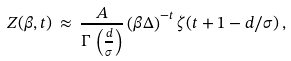Convert formula to latex. <formula><loc_0><loc_0><loc_500><loc_500>Z ( \beta , t ) \, \approx \, \frac { A } { \Gamma \, \left ( \frac { d } { \sigma } \right ) } \left ( \beta \Delta \right ) ^ { - t } \zeta ( t + 1 - d / \sigma ) \, ,</formula> 